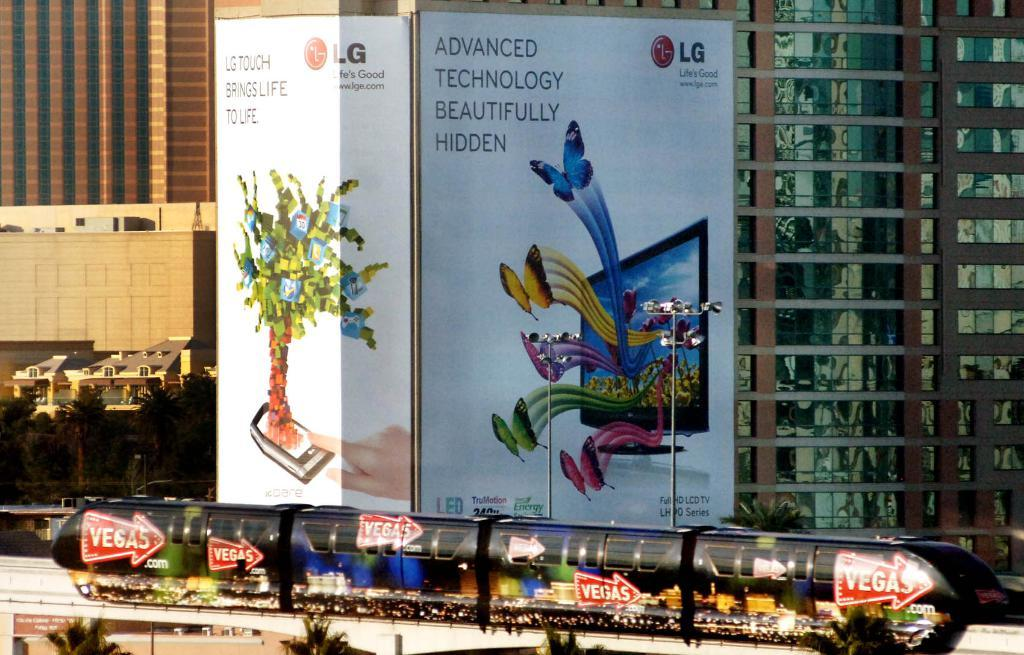<image>
Offer a succinct explanation of the picture presented. An ad for LG Touch on the side of a building. 